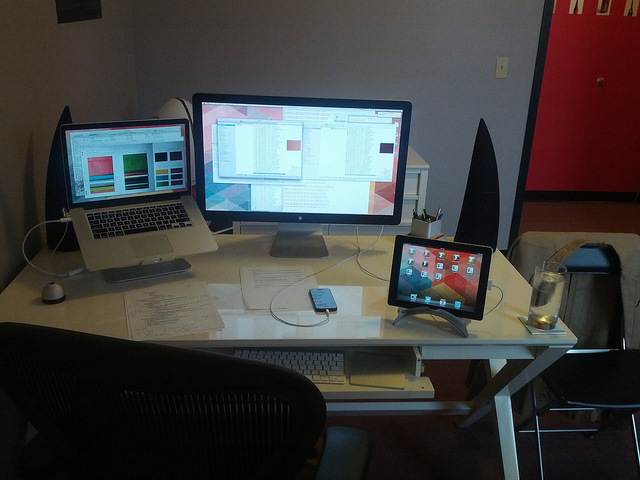How many computers are on the desk? 3 